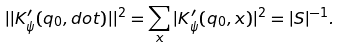Convert formula to latex. <formula><loc_0><loc_0><loc_500><loc_500>| | K ^ { \prime } _ { \psi } ( q _ { 0 } , d o t ) | | ^ { 2 } = \sum _ { x } | K ^ { \prime } _ { \psi } ( q _ { 0 } , x ) | ^ { 2 } = | S | ^ { - 1 } .</formula> 